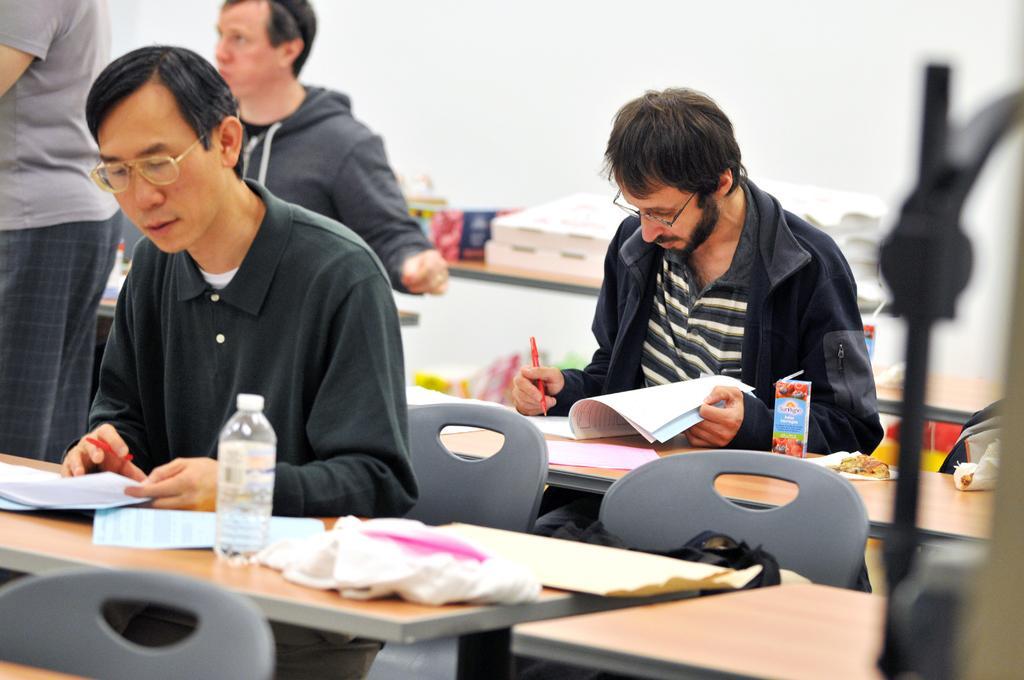Describe this image in one or two sentences. In this picture there are group of people those who are sitting on a chair and there is a table in front of them and they are writing something in there books, it seems to be a class view. 